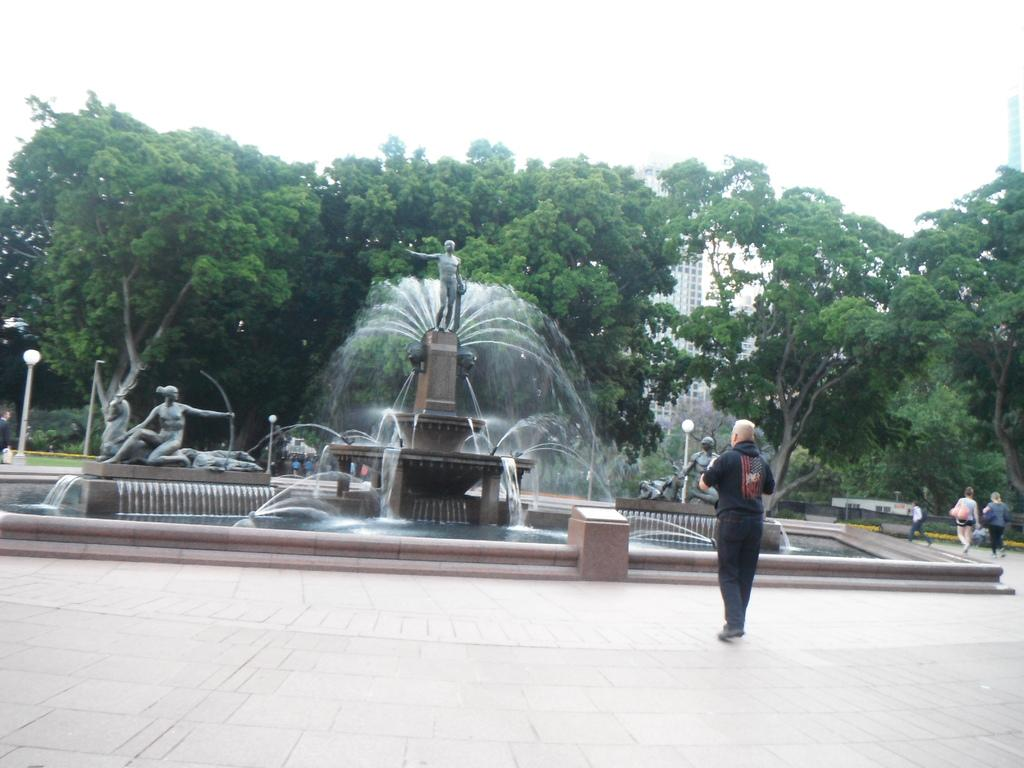How many people are in the group visible in the image? There is a group of people standing in the image, but the exact number cannot be determined from the provided facts. What type of structures can be seen in the image? There are fountains, sculptures, poles, lights, trees, and a building visible in the image. What is visible in the background of the image? The sky is visible in the background of the image. How many dimes are scattered on the ground in the image? There is no mention of dimes in the provided facts, so we cannot determine if any are present in the image. Is there any evidence of an attack in the image? There is no mention of an attack or any related elements in the provided facts, so we cannot determine if there is any evidence of an attack in the image. 